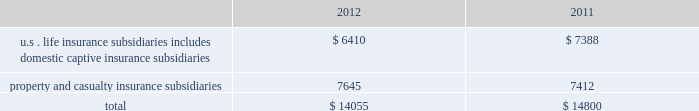Table of contents statutory surplus the table below sets forth statutory surplus for the company 2019s insurance companies as of december 31 , 2012 and 2011: .
Statutory capital and surplus for the u.s .
Life insurance subsidiaries , including domestic captive insurance subsidiaries , decreased by $ 978 , primarily due to variable annuity surplus impacts of approximately $ 425 , a $ 200 increase in reserves on a change in valuation basis , $ 200 transfer of the mutual funds business from the u.s .
Life insurance companies to the life holding company , and an increase in the asset valuation reserve of $ 115 .
As a result of the january 2013 statutory gain from the sale of the retirement plans and individual life businesses , the company's pro forma january 2 , 2013 u.s .
Life statutory surplus was estimated to be $ 8.1 billion , before approximately $ 1.5 billion in extraordinary dividends and return of capital to hfsg holding company .
Statutory capital and surplus for the property and casualty insurance subsidiaries increased by $ 233 , primarily due to statutory net income , after tax , of $ 727 , unrealized gains of $ 249 , and an increase in statutory admitted deferred tax assets of $ 77 , capital contributions of $ 14 , and an increase of statutory admitted assets of $ 7 , partially offset by dividends to the hfsg holding company of $ 841 .
Both net income and dividends are net of interest payments and dividends , respectively , on an intercompany note between hartford holdings , inc .
And hartford fire insurance company .
The company also holds regulatory capital and surplus for its operations in japan .
Under the accounting practices and procedures governed by japanese regulatory authorities , the company 2019s statutory capital and surplus was $ 1.1 billion and $ 1.3 billion as of december 31 , 2012 and 2011 , respectively .
Statutory capital the company 2019s stockholders 2019 equity , as prepared using u.s .
Generally accepted accounting principles ( 201cu.s .
Gaap 201d ) was $ 22.4 billion as of december 31 , 2012 .
The company 2019s estimated aggregate statutory capital and surplus , as prepared in accordance with the national association of insurance commissioners 2019 accounting practices and procedures manual ( 201cu.s .
Stat 201d ) was $ 14.1 billion as of december 31 , 2012 .
Significant differences between u.s .
Gaap stockholders 2019 equity and aggregate statutory capital and surplus prepared in accordance with u.s .
Stat include the following : 2022 u.s .
Stat excludes equity of non-insurance and foreign insurance subsidiaries not held by u.s .
Insurance subsidiaries .
2022 costs incurred by the company to acquire insurance policies are deferred under u.s .
Gaap while those costs are expensed immediately under u.s .
2022 temporary differences between the book and tax basis of an asset or liability which are recorded as deferred tax assets are evaluated for recoverability under u.s .
Gaap while those amounts deferred are subject to limitations under u.s .
Stat .
2022 the assumptions used in the determination of life benefit reserves is prescribed under u.s .
Stat , while the assumptions used under u.s .
Gaap are generally the company 2019s best estimates .
The methodologies for determining life insurance reserve amounts may also be different .
For example , reserving for living benefit reserves under u.s .
Stat is generally addressed by the commissioners 2019 annuity reserving valuation methodology and the related actuarial guidelines , while under u.s .
Gaap , those same living benefits may be considered embedded derivatives and recorded at fair value or they may be considered sop 03-1 reserves .
The sensitivity of these life insurance reserves to changes in equity markets , as applicable , will be different between u.s .
Gaap and u.s .
Stat .
2022 the difference between the amortized cost and fair value of fixed maturity and other investments , net of tax , is recorded as an increase or decrease to the carrying value of the related asset and to equity under u.s .
Gaap , while u.s .
Stat only records certain securities at fair value , such as equity securities and certain lower rated bonds required by the naic to be recorded at the lower of amortized cost or fair value .
2022 u.s .
Stat for life insurance companies establishes a formula reserve for realized and unrealized losses due to default and equity risks associated with certain invested assets ( the asset valuation reserve ) , while u.s .
Gaap does not .
Also , for those realized gains and losses caused by changes in interest rates , u.s .
Stat for life insurance companies defers and amortizes the gains and losses , caused by changes in interest rates , into income over the original life to maturity of the asset sold ( the interest maintenance reserve ) while u.s .
Gaap does not .
2022 goodwill arising from the acquisition of a business is tested for recoverability on an annual basis ( or more frequently , as necessary ) for u.s .
Gaap , while under u.s .
Stat goodwill is amortized over a period not to exceed 10 years and the amount of goodwill is limited. .
What is the growth rate in the statutory capital and surplus for the property and casualty insurance subsidiaries? 
Computations: (7645 - 7412)
Answer: 233.0. 